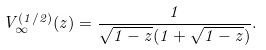Convert formula to latex. <formula><loc_0><loc_0><loc_500><loc_500>V _ { \infty } ^ { ( 1 / 2 ) } ( z ) = \frac { 1 } { \sqrt { 1 - z } ( 1 + \sqrt { 1 - z } ) } .</formula> 